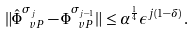<formula> <loc_0><loc_0><loc_500><loc_500>\| \hat { \Phi } _ { \ v P } ^ { \sigma _ { j } } - \Phi _ { \ v P } ^ { \sigma _ { j - 1 } } \| \leq \alpha ^ { \frac { 1 } { 4 } } \epsilon ^ { j ( 1 - \delta ) } \, .</formula> 